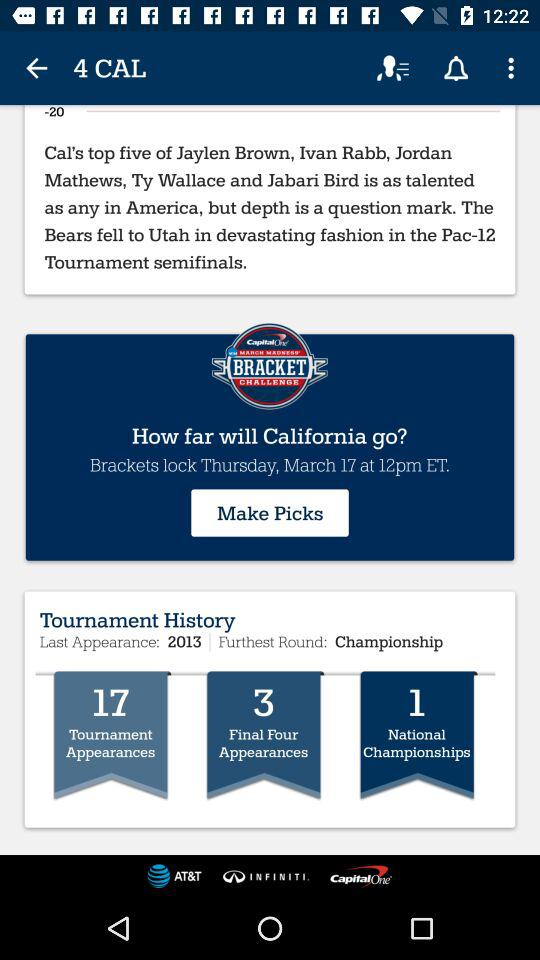How many more tournament appearances does California have than finals four appearances?
Answer the question using a single word or phrase. 14 